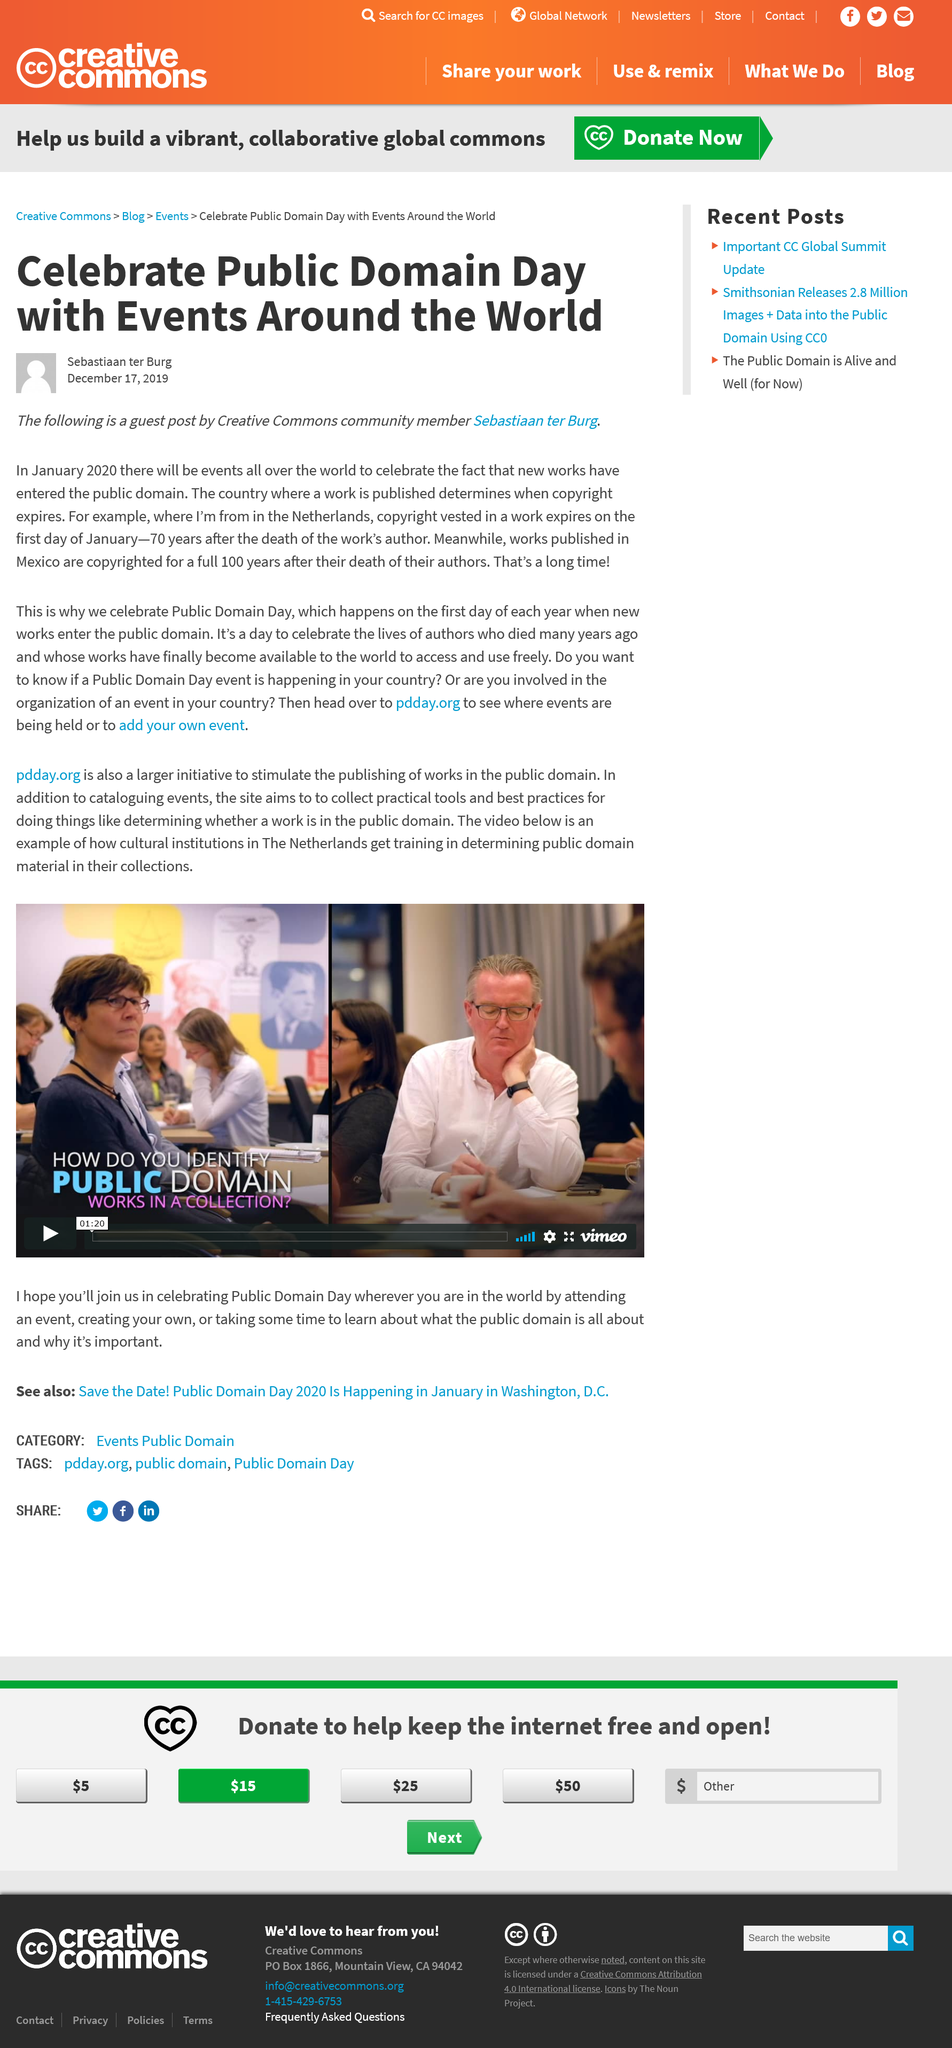Identify some key points in this picture. Sebastian ter Burg, the author of this article, is from The Netherlands. In 2020, events will be held in January to celebrate Public Domain Day. The works of the author are copyrighted in Mexico for a period of 100 years. 